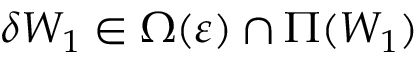Convert formula to latex. <formula><loc_0><loc_0><loc_500><loc_500>\delta W _ { 1 } \in \Omega ( \varepsilon ) \cap \Pi ( W _ { 1 } )</formula> 